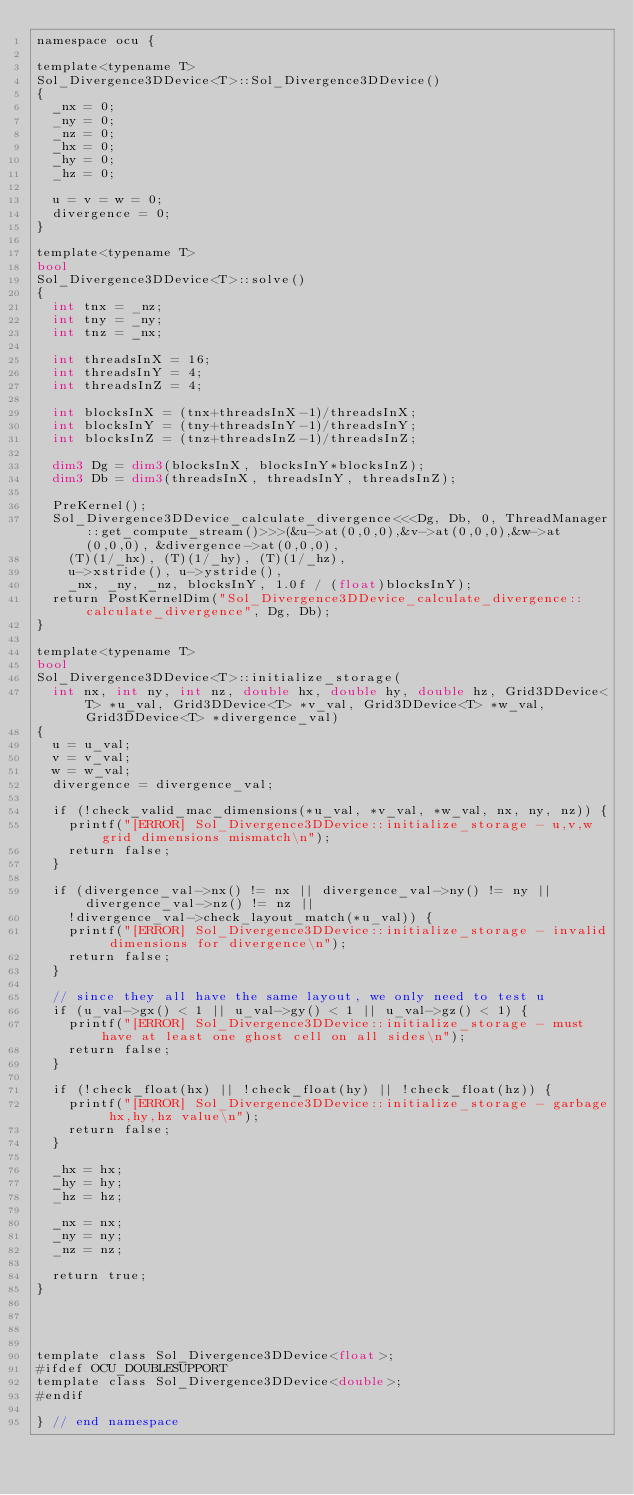<code> <loc_0><loc_0><loc_500><loc_500><_Cuda_>namespace ocu {

template<typename T>
Sol_Divergence3DDevice<T>::Sol_Divergence3DDevice()
{
  _nx = 0;
  _ny = 0;
  _nz = 0;
  _hx = 0;
  _hy = 0;
  _hz = 0;

  u = v = w = 0;
  divergence = 0;
}

template<typename T>
bool
Sol_Divergence3DDevice<T>::solve()
{
  int tnx = _nz;
  int tny = _ny;
  int tnz = _nx;

  int threadsInX = 16;
  int threadsInY = 4;
  int threadsInZ = 4;

  int blocksInX = (tnx+threadsInX-1)/threadsInX;
  int blocksInY = (tny+threadsInY-1)/threadsInY;
  int blocksInZ = (tnz+threadsInZ-1)/threadsInZ;

  dim3 Dg = dim3(blocksInX, blocksInY*blocksInZ);
  dim3 Db = dim3(threadsInX, threadsInY, threadsInZ);

  PreKernel();
  Sol_Divergence3DDevice_calculate_divergence<<<Dg, Db, 0, ThreadManager::get_compute_stream()>>>(&u->at(0,0,0),&v->at(0,0,0),&w->at(0,0,0), &divergence->at(0,0,0),
    (T)(1/_hx), (T)(1/_hy), (T)(1/_hz), 
    u->xstride(), u->ystride(), 
    _nx, _ny, _nz, blocksInY, 1.0f / (float)blocksInY);
  return PostKernelDim("Sol_Divergence3DDevice_calculate_divergence::calculate_divergence", Dg, Db);
}

template<typename T>
bool 
Sol_Divergence3DDevice<T>::initialize_storage(
  int nx, int ny, int nz, double hx, double hy, double hz, Grid3DDevice<T> *u_val, Grid3DDevice<T> *v_val, Grid3DDevice<T> *w_val, Grid3DDevice<T> *divergence_val)
{
  u = u_val;
  v = v_val;
  w = w_val;
  divergence = divergence_val;

  if (!check_valid_mac_dimensions(*u_val, *v_val, *w_val, nx, ny, nz)) {
    printf("[ERROR] Sol_Divergence3DDevice::initialize_storage - u,v,w grid dimensions mismatch\n");
    return false;
  }

  if (divergence_val->nx() != nx || divergence_val->ny() != ny || divergence_val->nz() != nz ||
    !divergence_val->check_layout_match(*u_val)) {
    printf("[ERROR] Sol_Divergence3DDevice::initialize_storage - invalid dimensions for divergence\n");
    return false;
  }

  // since they all have the same layout, we only need to test u
  if (u_val->gx() < 1 || u_val->gy() < 1 || u_val->gz() < 1) {
    printf("[ERROR] Sol_Divergence3DDevice::initialize_storage - must have at least one ghost cell on all sides\n");
    return false;
  }

  if (!check_float(hx) || !check_float(hy) || !check_float(hz)) {
    printf("[ERROR] Sol_Divergence3DDevice::initialize_storage - garbage hx,hy,hz value\n");
    return false;
  }

  _hx = hx;
  _hy = hy;
  _hz = hz;

  _nx = nx;
  _ny = ny;
  _nz = nz;

  return true;
}




template class Sol_Divergence3DDevice<float>;
#ifdef OCU_DOUBLESUPPORT
template class Sol_Divergence3DDevice<double>;
#endif

} // end namespace

</code> 